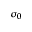Convert formula to latex. <formula><loc_0><loc_0><loc_500><loc_500>\sigma _ { 0 }</formula> 